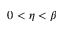<formula> <loc_0><loc_0><loc_500><loc_500>0 < \eta < \beta</formula> 